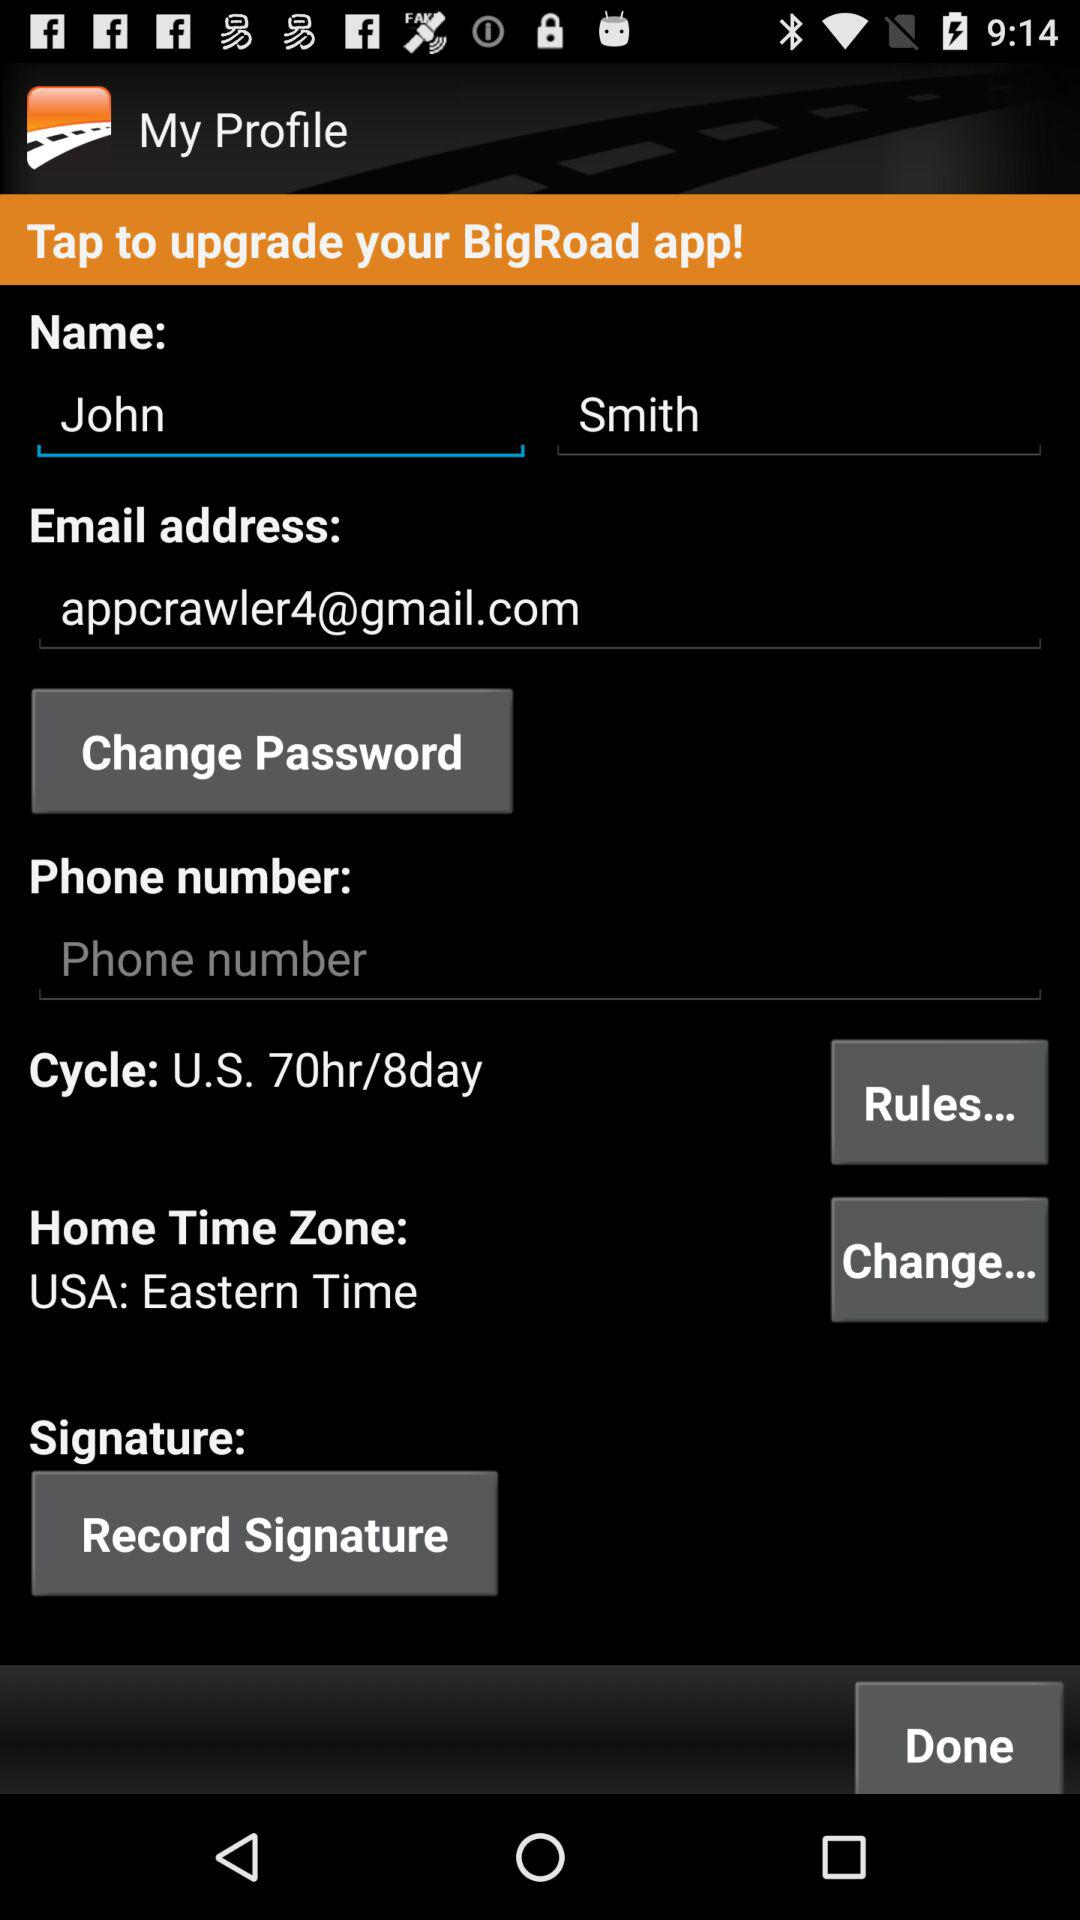What is the name? The name is John Smith. 